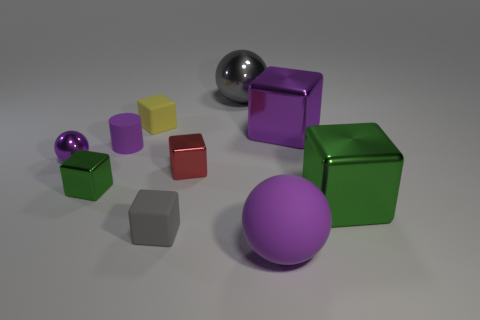What is the color of the small object that is the same shape as the large gray shiny thing?
Provide a succinct answer. Purple. Are there more tiny metallic things to the left of the red metal thing than big purple spheres?
Make the answer very short. Yes. What is the color of the small block that is behind the small red block?
Provide a short and direct response. Yellow. Is the matte cylinder the same size as the purple metal ball?
Ensure brevity in your answer.  Yes. How big is the gray rubber cube?
Your answer should be very brief. Small. The tiny rubber object that is the same color as the rubber sphere is what shape?
Offer a very short reply. Cylinder. Is the number of tiny purple metal objects greater than the number of green blocks?
Your response must be concise. No. There is a big block that is in front of the tiny green thing that is behind the big metal thing that is in front of the purple metal sphere; what is its color?
Your response must be concise. Green. Do the large purple thing behind the big purple rubber thing and the big rubber object have the same shape?
Offer a very short reply. No. There is another shiny cube that is the same size as the red block; what color is it?
Your answer should be compact. Green. 